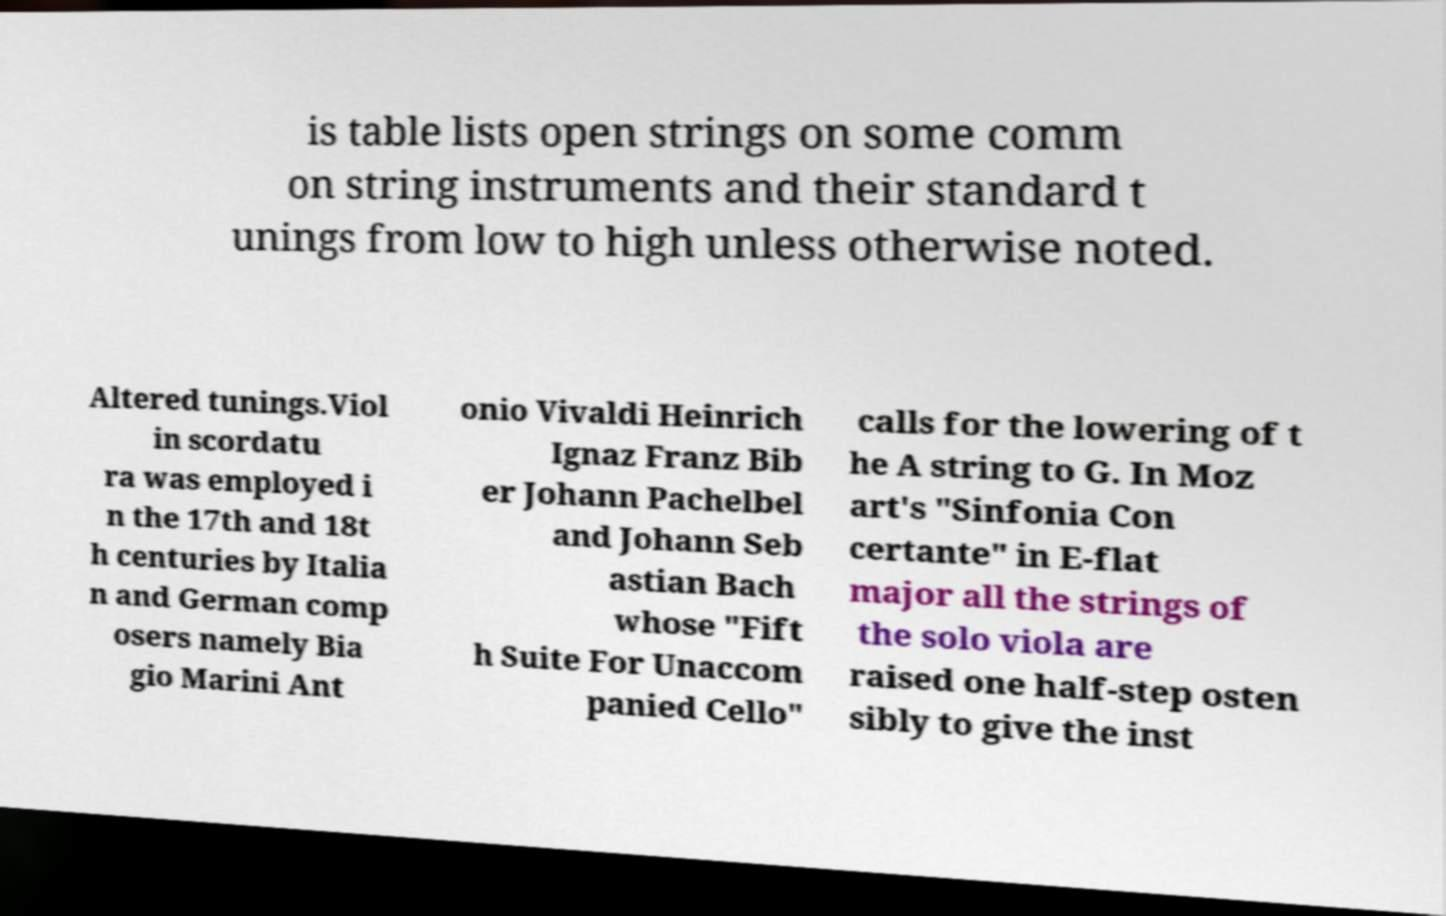Can you accurately transcribe the text from the provided image for me? is table lists open strings on some comm on string instruments and their standard t unings from low to high unless otherwise noted. Altered tunings.Viol in scordatu ra was employed i n the 17th and 18t h centuries by Italia n and German comp osers namely Bia gio Marini Ant onio Vivaldi Heinrich Ignaz Franz Bib er Johann Pachelbel and Johann Seb astian Bach whose "Fift h Suite For Unaccom panied Cello" calls for the lowering of t he A string to G. In Moz art's "Sinfonia Con certante" in E-flat major all the strings of the solo viola are raised one half-step osten sibly to give the inst 